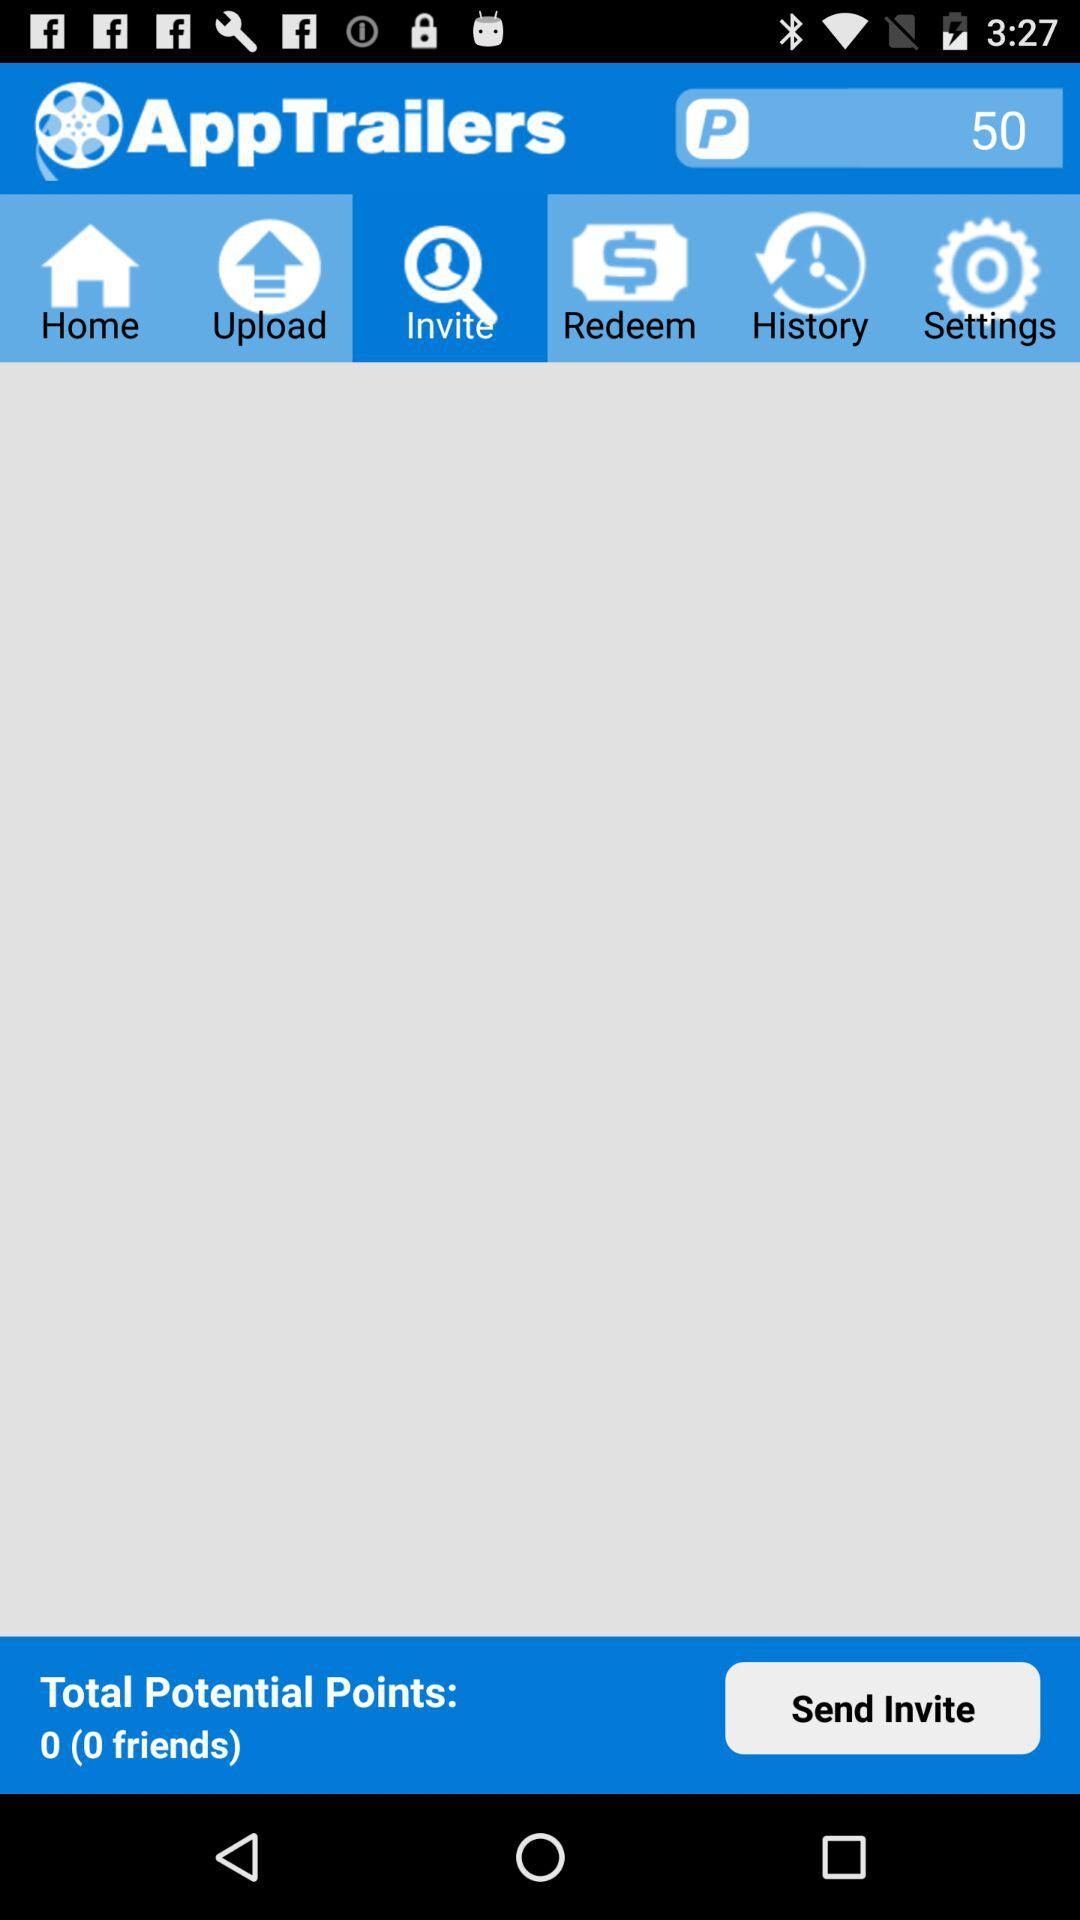How many friends do I have?
Answer the question using a single word or phrase. 0 